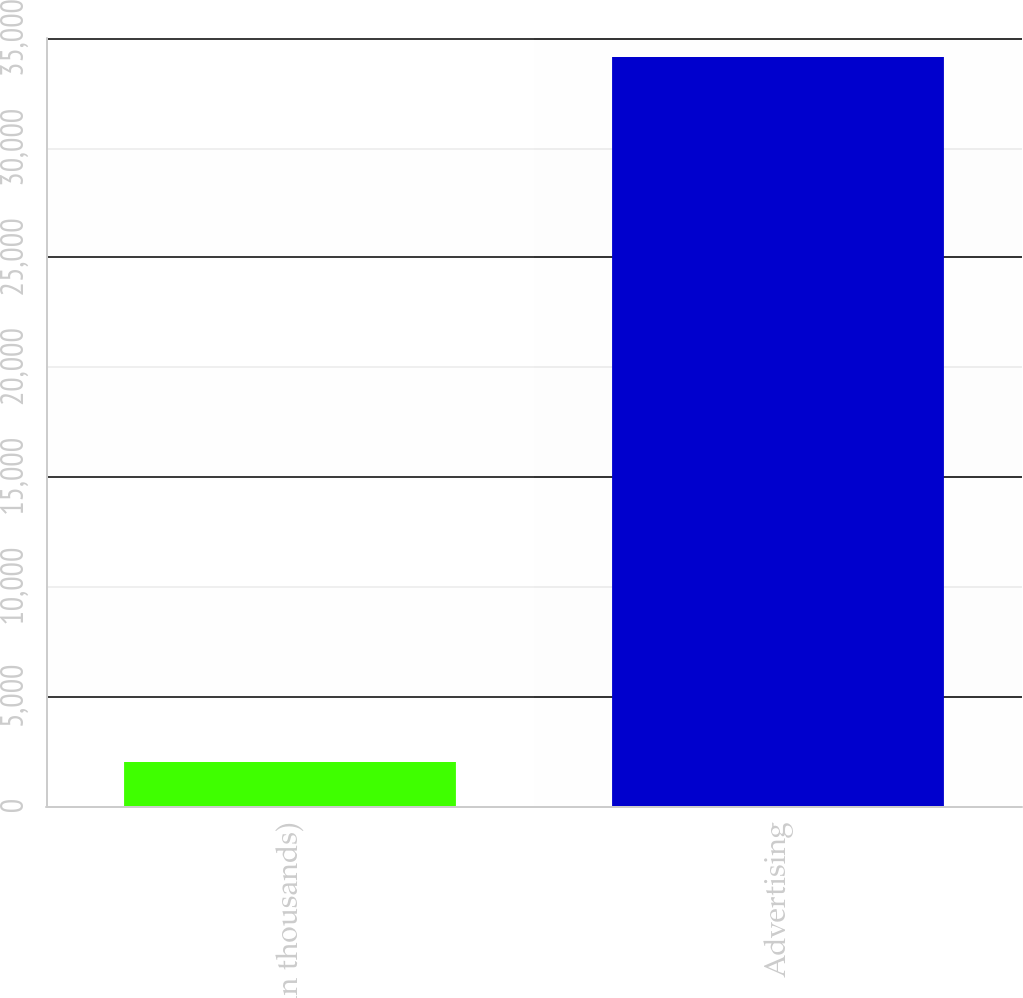Convert chart. <chart><loc_0><loc_0><loc_500><loc_500><bar_chart><fcel>(in thousands)<fcel>Advertising<nl><fcel>2005<fcel>34130<nl></chart> 